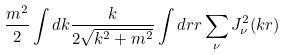Convert formula to latex. <formula><loc_0><loc_0><loc_500><loc_500>\frac { m ^ { 2 } } 2 \int d k \frac { k } { 2 \sqrt { k ^ { 2 } + m ^ { 2 } } } \int d r r \sum _ { \nu } J _ { \nu } ^ { 2 } ( k r )</formula> 